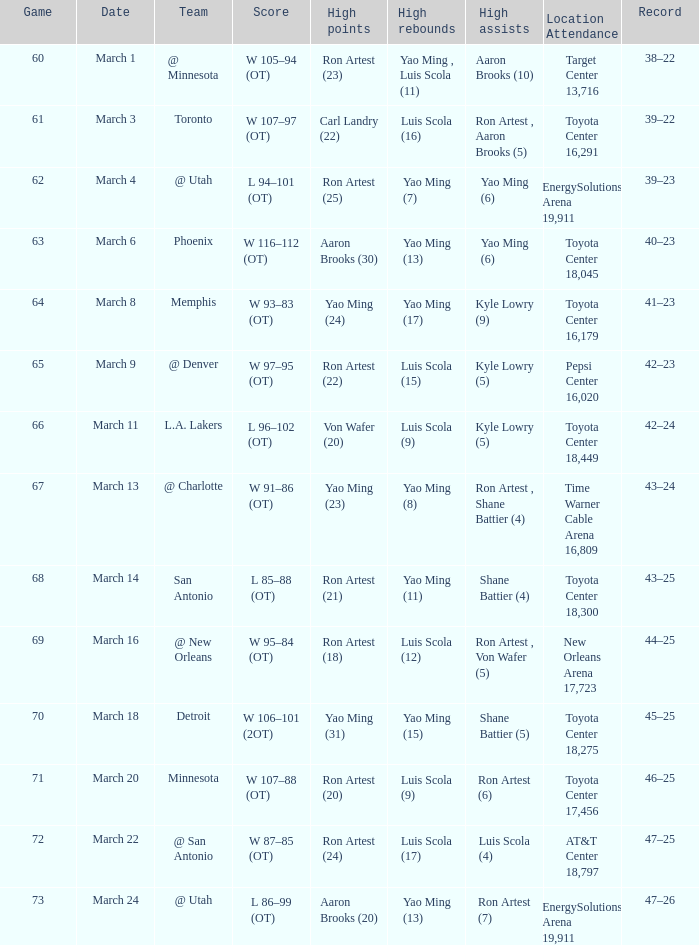Who had the most poinst in game 72? Ron Artest (24). 